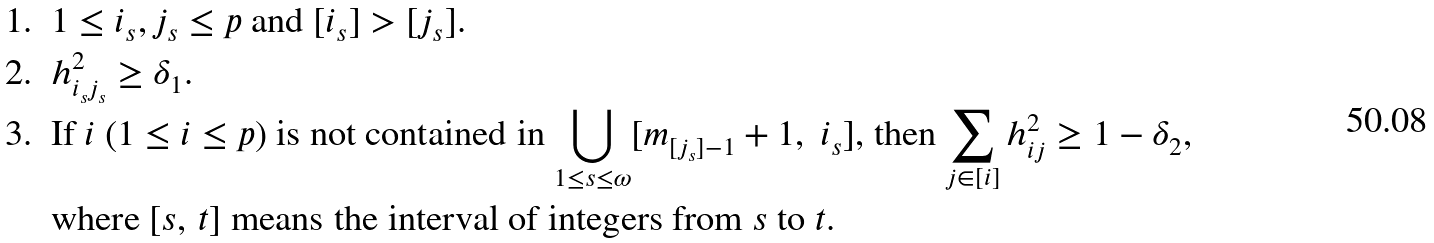Convert formula to latex. <formula><loc_0><loc_0><loc_500><loc_500>& 1 . \ \ 1 \leq i _ { s } , j _ { s } \leq p \text { and } [ i _ { s } ] > [ j _ { s } ] . \\ & 2 . \ \ h ^ { 2 } _ { i _ { s } j _ { s } } \geq \delta _ { 1 } . \\ & 3 . \ \text { If $i\ (1\leq i \leq p)$ is not contained in $\bigcup_{1\leq s \leq \omega} [m_{[j_{s}]-1}+1,\ i_{s}]$, then $\sum_{j\in [i]} h_{ij}^{2} \geq 1-\delta_{2}$} , \\ & \quad \text { where $[s,\,t]$ means the interval of integers from $s$ to $t$.}</formula> 